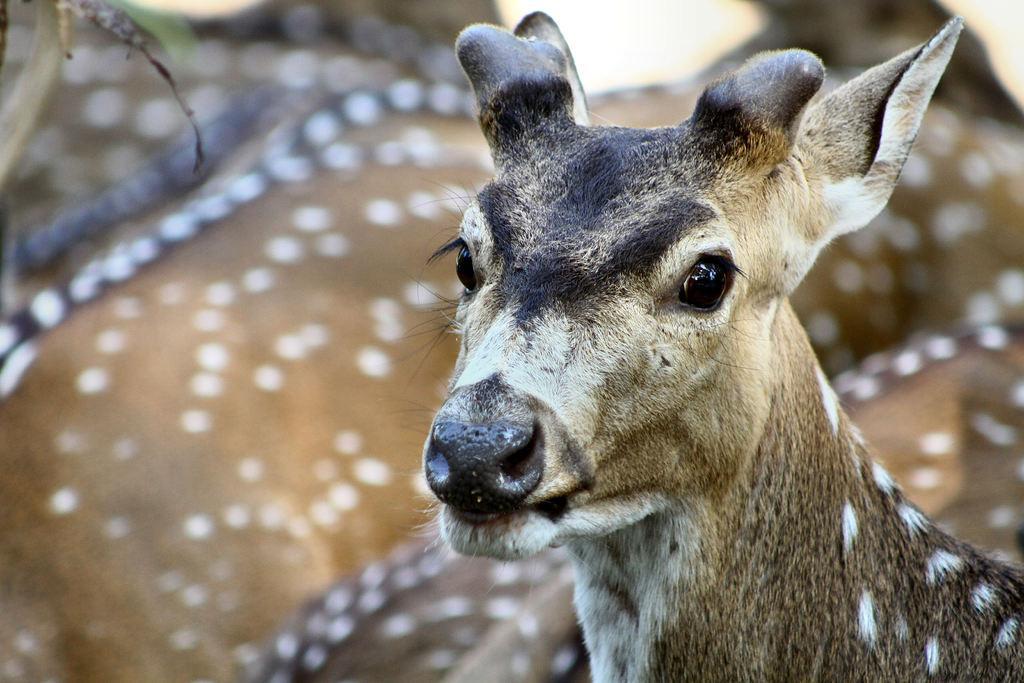In one or two sentences, can you explain what this image depicts? In this image there are a few deer. 